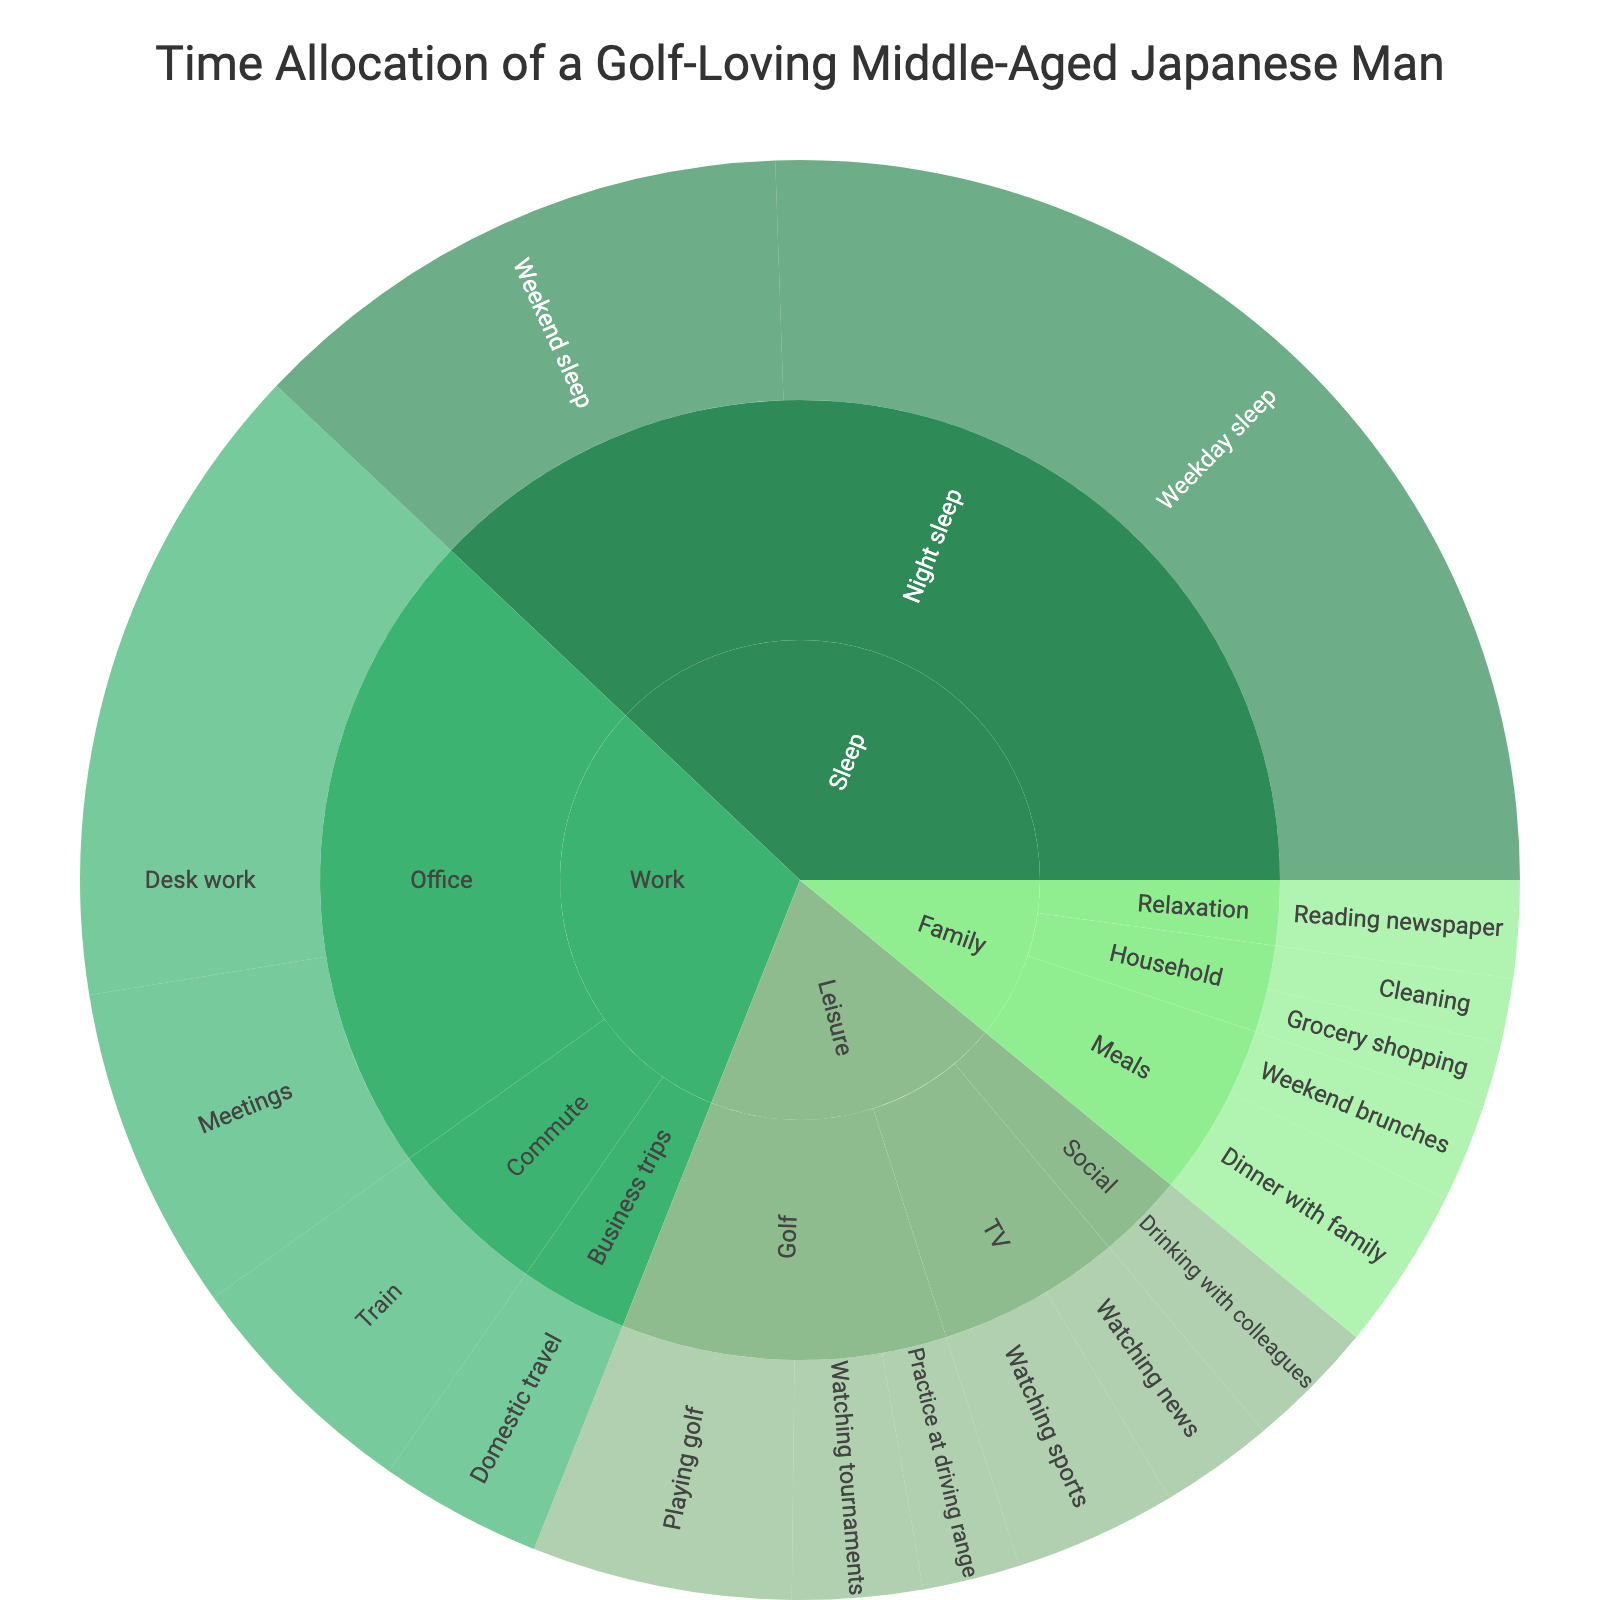What's the total number of hours spent on "Leisure" activities? To find the total hours spent on "Leisure" activities, sum up the hours of all the activities under the "Leisure" category: Playing golf (8) + Watching tournaments (4) + Practice at driving range (3) + Watching sports (5) + Watching news (3.5) + Drinking with colleagues (4). 8 + 4 + 3 + 5 + 3.5 + 4 = 27.5
Answer: 27.5 Which activity under "Work" has the highest number of hours allocated? Look at the "Work" category and compare the hours for each subcategory: Meetings (10), Desk work (20), Train (7.5), Domestic travel (5). Desk work has the highest number of hours at 20 hours.
Answer: Desk work How many hours are allocated to "Train" within the "Commute" subcategory? Look under the "Commute" subcategory of "Work" and find the hours allocated to "Train," which is listed as 7.5 hours.
Answer: 7.5 Between "Playing golf" and "Watching sports," which activity has more hours allocated? Compare the hours allocated to "Playing golf" (8 hours) and "Watching sports" (5 hours). "Playing golf" has 3 more hours allocated than "Watching sports."
Answer: Playing golf What is the title of the sunburst plot? The title is displayed prominently at the top of the sunburst plot. It reads "Time Allocation of a Golf-Loving Middle-Aged Japanese Man."
Answer: Time Allocation of a Golf-Loving Middle-Aged Japanese Man How many more hours does the middle-aged man spend on "Weekday sleep" compared to "Weekend sleep"? "Weekday sleep" has 35 hours allocated, while "Weekend sleep" has 17 hours. Subtract "Weekend sleep" from "Weekday sleep": 35 - 17 = 18.
Answer: 18 What's the total number of hours dedicated to the "Meals" subcategory under "Family"? Add the hours for Dinner with family (5) and Weekend brunches (3) under the "Meals" subcategory. 5 + 3 = 8.
Answer: 8 Which has more hours, "Reading newspaper" or all "Household" activities combined? "Reading newspaper" under "Family - Relaxation" has 3 hours. For "Household" activities (Grocery shopping and Cleaning), sum the hours: Grocery shopping (2) + Cleaning (2). 2 + 2 = 4. Since 4 hours for "Household" is greater than 3 hours for "Reading newspaper," "Household" has more hours.
Answer: Household In which category does the activity "Watching news" fall under and how many hours are dedicated to it? The activity "Watching news" falls under the "Leisure" category and the "TV" subcategory. The hours dedicated to it are listed as 3.5 hours.
Answer: Leisure, 3.5 